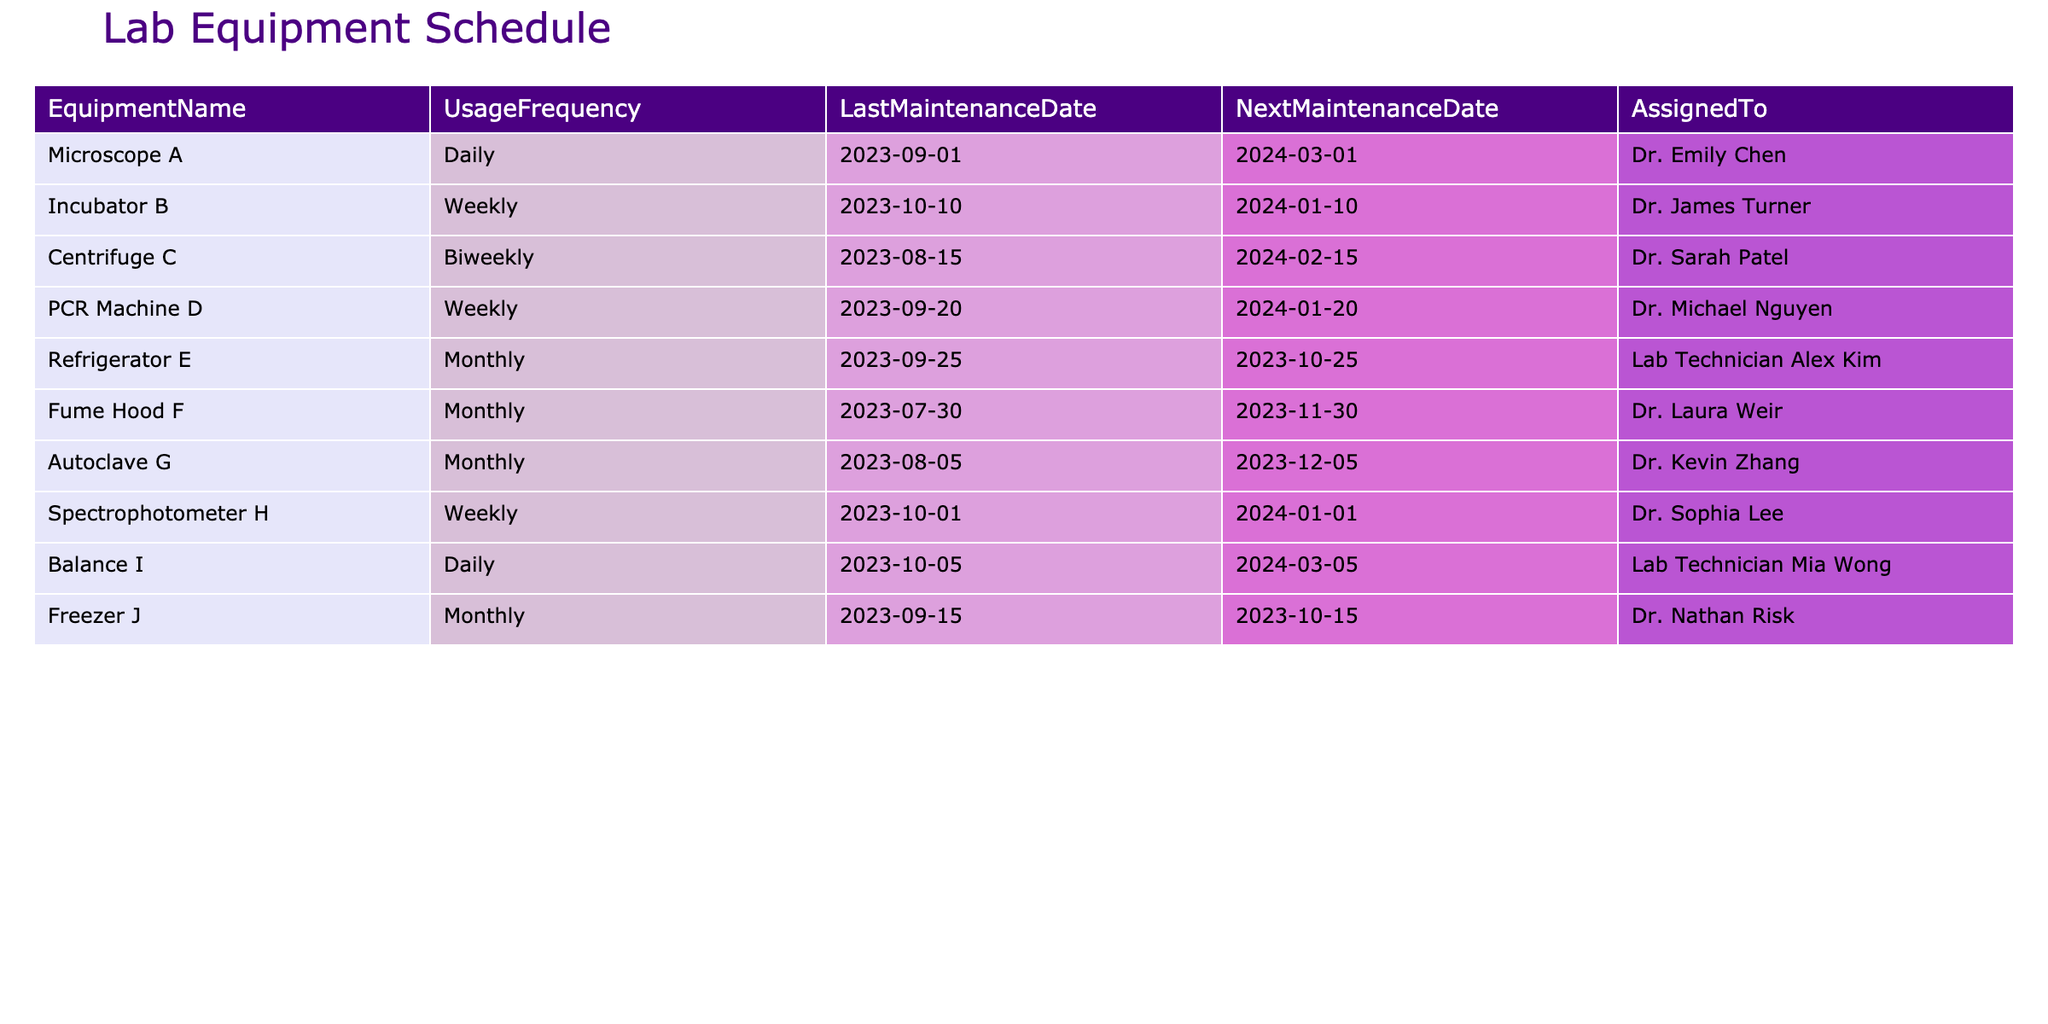What is the usage frequency of the PCR Machine D? The usage frequency is listed in the table under the "UsageFrequency" column. For the PCR Machine D, it is specified as "Weekly."
Answer: Weekly Which piece of equipment was last maintained on 2023-09-25? By checking the "LastMaintenanceDate" column in the table, we find that the equipment with this maintenance date is the Refrigerator E.
Answer: Refrigerator E How many pieces of equipment have a monthly maintenance schedule? We count the number of entries in the "NextMaintenanceDate" column that indicate a monthly frequency. The table shows four items: Refrigerator E, Fume Hood F, Autoclave G, and Freezer J, confirming that there are four pieces of equipment with monthly maintenance schedules.
Answer: 4 Is the Centrifuge C scheduled for maintenance before December 2023? Checking the "NextMaintenanceDate" for the Centrifuge C, which is 2024-02-15, shows that it is not scheduled for maintenance before December 2023. Thus the answer is no.
Answer: No What is the difference in usage frequency between the equipment with the most and least frequent usage? The equipment with the highest frequency is the Microscope A, used daily. The least frequent is the Centrifuge C, with biweekly usage. Daily equals 7 times a week, while biweekly equals 2 times a week. The difference is 7 - 2 = 5.
Answer: 5 Which Dr. is assigned to the Fume Hood F? The table provides the responsible individuals under the "AssignedTo" column, where we can find that Dr. Laura Weir is assigned to the Fume Hood F.
Answer: Dr. Laura Weir How many instruments in the lab are used daily? The "UsageFrequency" column shows that only the Microscope A and Balance I are used daily. Thus, there are two instruments that operate on a daily basis.
Answer: 2 What is the average interval in months for maintenance across all equipment? To determine the average, we first note the frequency of maintenance: Daily (no interval), Weekly (0.25 months), Biweekly (0.5 months), Monthly (1 month). Equipment with monthly maintenance schedules have 5 entries. The average will be (1*5 + 0.25*3 + 0.5*1) / 9 = (5 + 0.75 + 0.5) / 9 = 6.25 / 9 approximately equals 0.694 months.
Answer: 0.694 Is the assigned individual for the Autoclave G different from the individual assigned to the Spectrophotometer H? We can see from the "AssignedTo" column that the Autoclave G is assigned to Dr. Kevin Zhang, whereas the Spectrophotometer H is assigned to Dr. Sophia Lee. Since these are different individuals, the statement is true.
Answer: Yes 